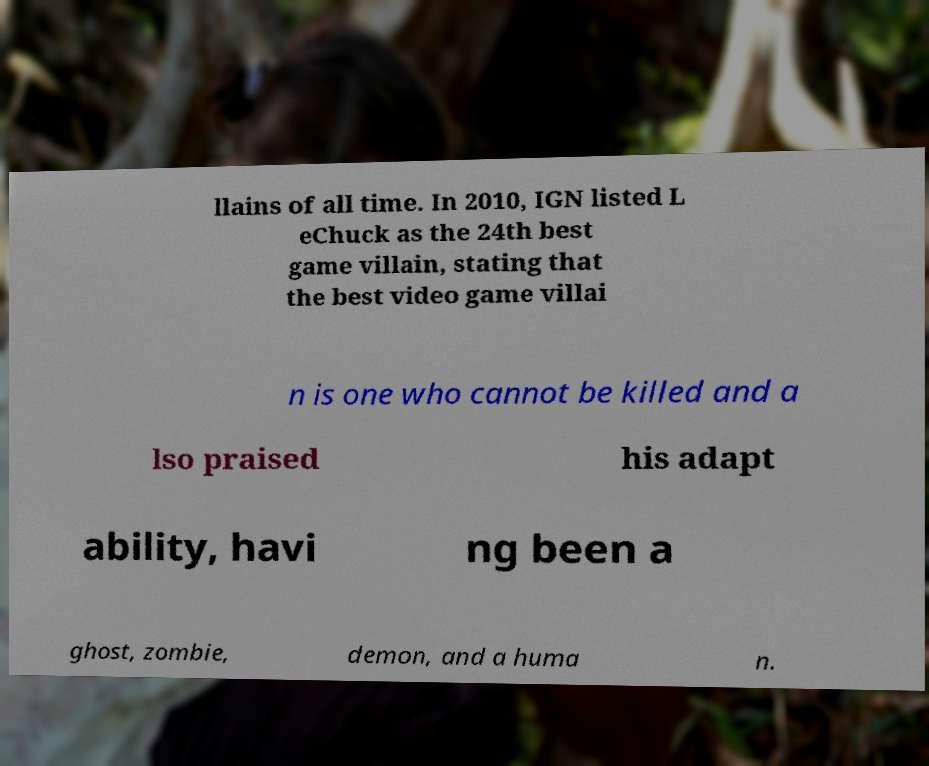Can you read and provide the text displayed in the image?This photo seems to have some interesting text. Can you extract and type it out for me? llains of all time. In 2010, IGN listed L eChuck as the 24th best game villain, stating that the best video game villai n is one who cannot be killed and a lso praised his adapt ability, havi ng been a ghost, zombie, demon, and a huma n. 